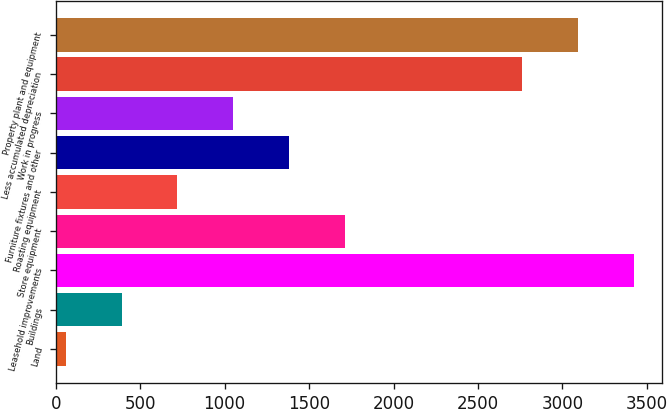Convert chart to OTSL. <chart><loc_0><loc_0><loc_500><loc_500><bar_chart><fcel>Land<fcel>Buildings<fcel>Leasehold improvements<fcel>Store equipment<fcel>Roasting equipment<fcel>Furniture fixtures and other<fcel>Work in progress<fcel>Less accumulated depreciation<fcel>Property plant and equipment<nl><fcel>59.1<fcel>389.5<fcel>3421.7<fcel>1711.1<fcel>719.9<fcel>1380.7<fcel>1050.3<fcel>2760.9<fcel>3091.3<nl></chart> 